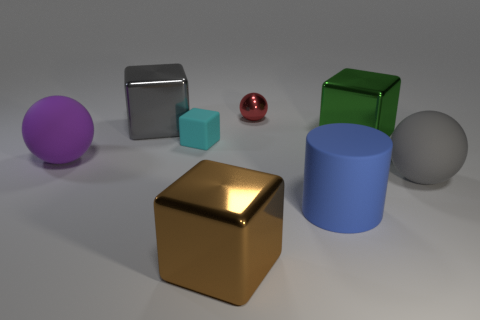The large matte cylinder is what color?
Your answer should be compact. Blue. What size is the matte sphere that is to the left of the big metal block in front of the sphere to the right of the large green shiny object?
Your response must be concise. Large. How many other things are there of the same shape as the large purple rubber object?
Your answer should be compact. 2. There is a large cube that is both behind the blue thing and left of the large blue object; what color is it?
Keep it short and to the point. Gray. Is there any other thing that is the same size as the gray block?
Ensure brevity in your answer.  Yes. There is a shiny block that is in front of the gray sphere; is its color the same as the small sphere?
Give a very brief answer. No. What number of cylinders are large gray metal objects or tiny metallic objects?
Offer a terse response. 0. There is a large gray thing left of the small red sphere; what is its shape?
Your answer should be compact. Cube. The large metal object in front of the sphere that is to the left of the small object to the left of the red metallic ball is what color?
Make the answer very short. Brown. Is the material of the large purple object the same as the green cube?
Offer a very short reply. No. 